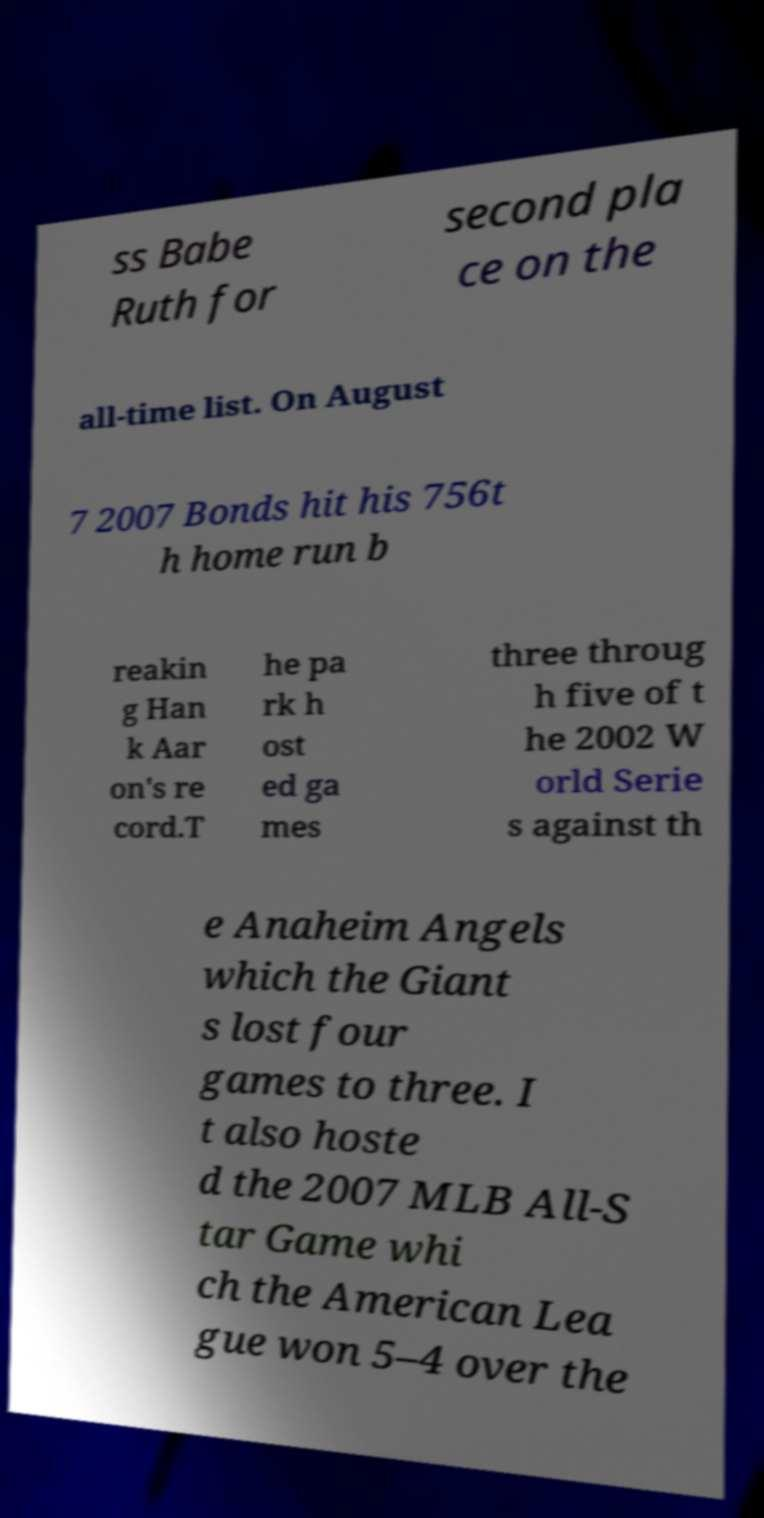For documentation purposes, I need the text within this image transcribed. Could you provide that? ss Babe Ruth for second pla ce on the all-time list. On August 7 2007 Bonds hit his 756t h home run b reakin g Han k Aar on's re cord.T he pa rk h ost ed ga mes three throug h five of t he 2002 W orld Serie s against th e Anaheim Angels which the Giant s lost four games to three. I t also hoste d the 2007 MLB All-S tar Game whi ch the American Lea gue won 5–4 over the 